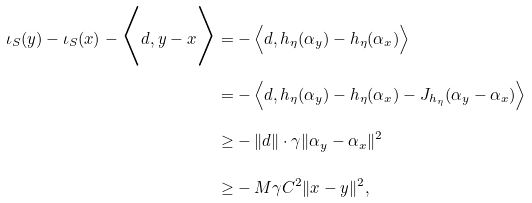<formula> <loc_0><loc_0><loc_500><loc_500>\iota _ { S } ( y ) - \iota _ { S } ( x ) - \Big < d , y - x \Big > = & - \Big < d , h _ { \eta } ( \alpha _ { y } ) - h _ { \eta } ( \alpha _ { x } ) \Big > \\ = & - \Big < d , h _ { \eta } ( \alpha _ { y } ) - h _ { \eta } ( \alpha _ { x } ) - J _ { h _ { \eta } } ( \alpha _ { y } - \alpha _ { x } ) \Big > \\ \geq & - \| d \| \cdot \gamma \| \alpha _ { y } - \alpha _ { x } \| ^ { 2 } \\ \geq & - M \gamma C ^ { 2 } \| x - y \| ^ { 2 } ,</formula> 